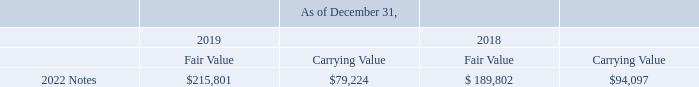As of December 31, 2019 and 2018, the fair value of the 2022 Notes, which was determined based on inputs that are observable in the market or that could be derived from, or corroborated with, observable market data, quoted price of the 2022 Notes in an over-the-counter market (Level 2), and carrying value of debt instruments (carrying value excludes the equity component of the Company’s convertible notes classified in equity) were as follows (in thousands):
In connection with the issuance of the 2022 Notes, the Company entered into capped call transactions with certain counterparties affiliated with the initial purchasers and others. The capped call transactions are expected to reduce potential dilution of earnings per share upon conversion of the 2022 Notes.
Under the capped call transactions, the Company purchased capped call options that in the aggregate relate to the total number of shares of the Company’s common stock underlying the 2022 Notes, with an initial strike price of approximately $33.71 per share, which corresponds to the initial conversion price of the 2022 Notes and is subject to anti-dilution adjustments substantially similar to those applicable to the conversion rate of the 2022 Notes, and have a cap price of approximately $47.20.
The cost of the purchased capped calls of $12.9 million was recorded to shareholders’ equity and will not be re-measured.
Based on the closing price of the Company’s common stock of $78.08 on December 31, 2019, the if-converted value of the 2022 Notes was more than their respective principal amounts.
What was the cost of the purchased capped calls? The cost of the purchased capped calls of $12.9 million was recorded to shareholders’ equity and will not be re-measured. What is the average fair value for the period December 31, 2019 to December 31, 2018?
Answer scale should be: thousand. (215,801+189,802) / 2
Answer: 202801.5. What is the average Carrying Value for the period December 31, 2019 to December 31, 2018?
Answer scale should be: thousand. (79,224+94,097) / 2
Answer: 86660.5. In which year was the 2022 Notes fair value less than 200,000 thousands? Locate and analyze 2022 notes in row 4
answer: 2018. What was the initial strike price? $33.71 per share. What was the 2022 Notes cap price? $47.20. 